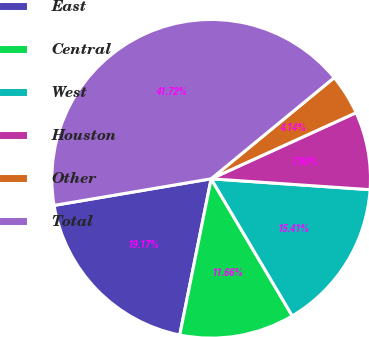Convert chart to OTSL. <chart><loc_0><loc_0><loc_500><loc_500><pie_chart><fcel>East<fcel>Central<fcel>West<fcel>Houston<fcel>Other<fcel>Total<nl><fcel>19.17%<fcel>11.66%<fcel>15.41%<fcel>7.9%<fcel>4.14%<fcel>41.72%<nl></chart> 